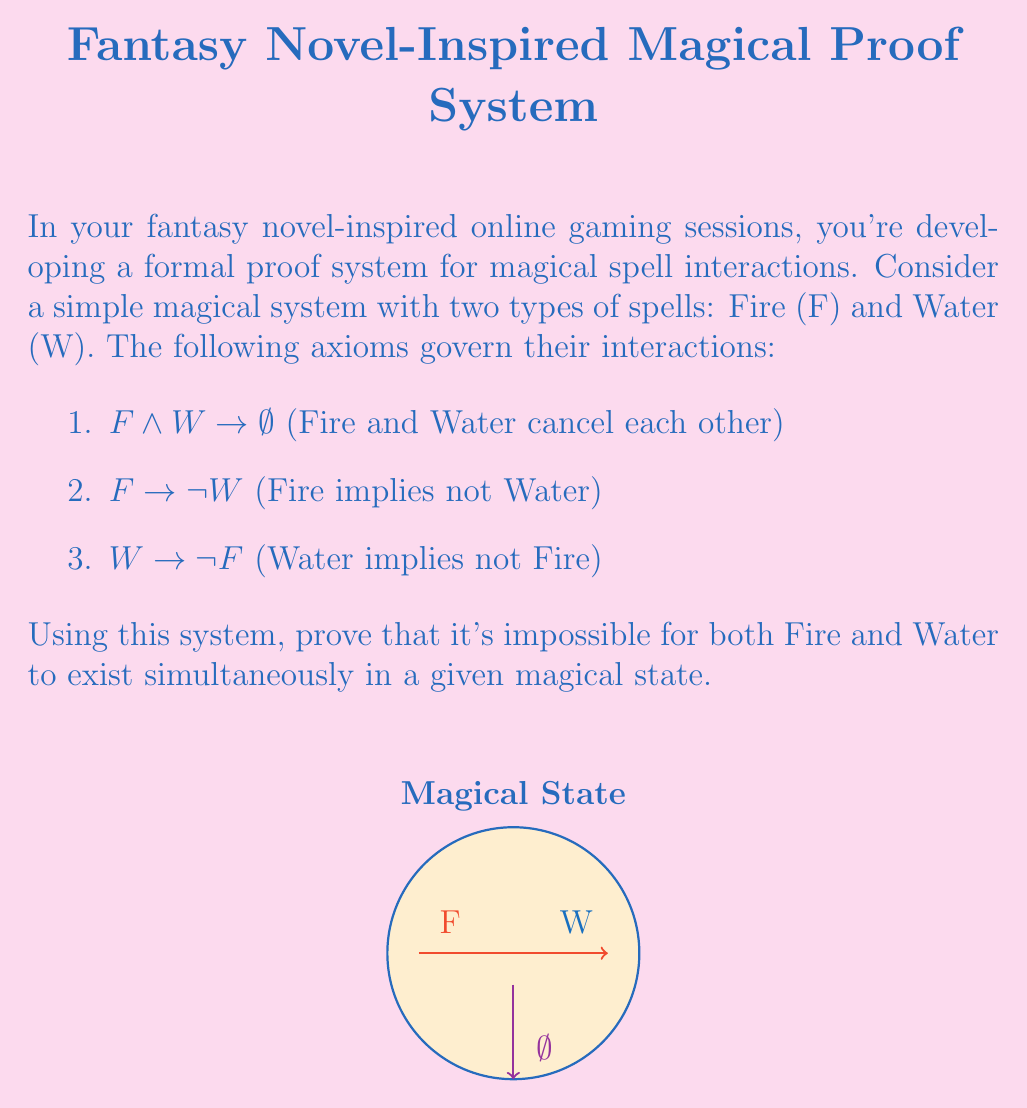Provide a solution to this math problem. Let's approach this proof step-by-step using the given axioms and principles of propositional logic:

1) We start by assuming the opposite of what we want to prove, i.e., both Fire and Water exist simultaneously:

   $$F ∧ W$$

2) From axiom 1, we know that:

   $$F ∧ W → ∅$$

3) By Modus Ponens, if we have $F ∧ W$ (step 1) and $F ∧ W → ∅$ (step 2), we can conclude:

   $$∅$$

4) However, ∅ represents an impossible magical state. This contradiction shows that our initial assumption (F ∧ W) must be false.

5) We can also prove this another way using axioms 2 and 3:

   From axiom 2: $$F → ¬W$$
   From axiom 3: $$W → ¬F$$

6) If we assume F is true, then ¬W must be true (from axiom 2).
   If we assume W is true, then ¬F must be true (from axiom 3).

7) This means F and W cannot be simultaneously true, as each implies the negation of the other.

Thus, we have proven that it's impossible for both Fire and Water to exist simultaneously in a given magical state using our formal proof system.
Answer: Proof by contradiction and mutual exclusivity 